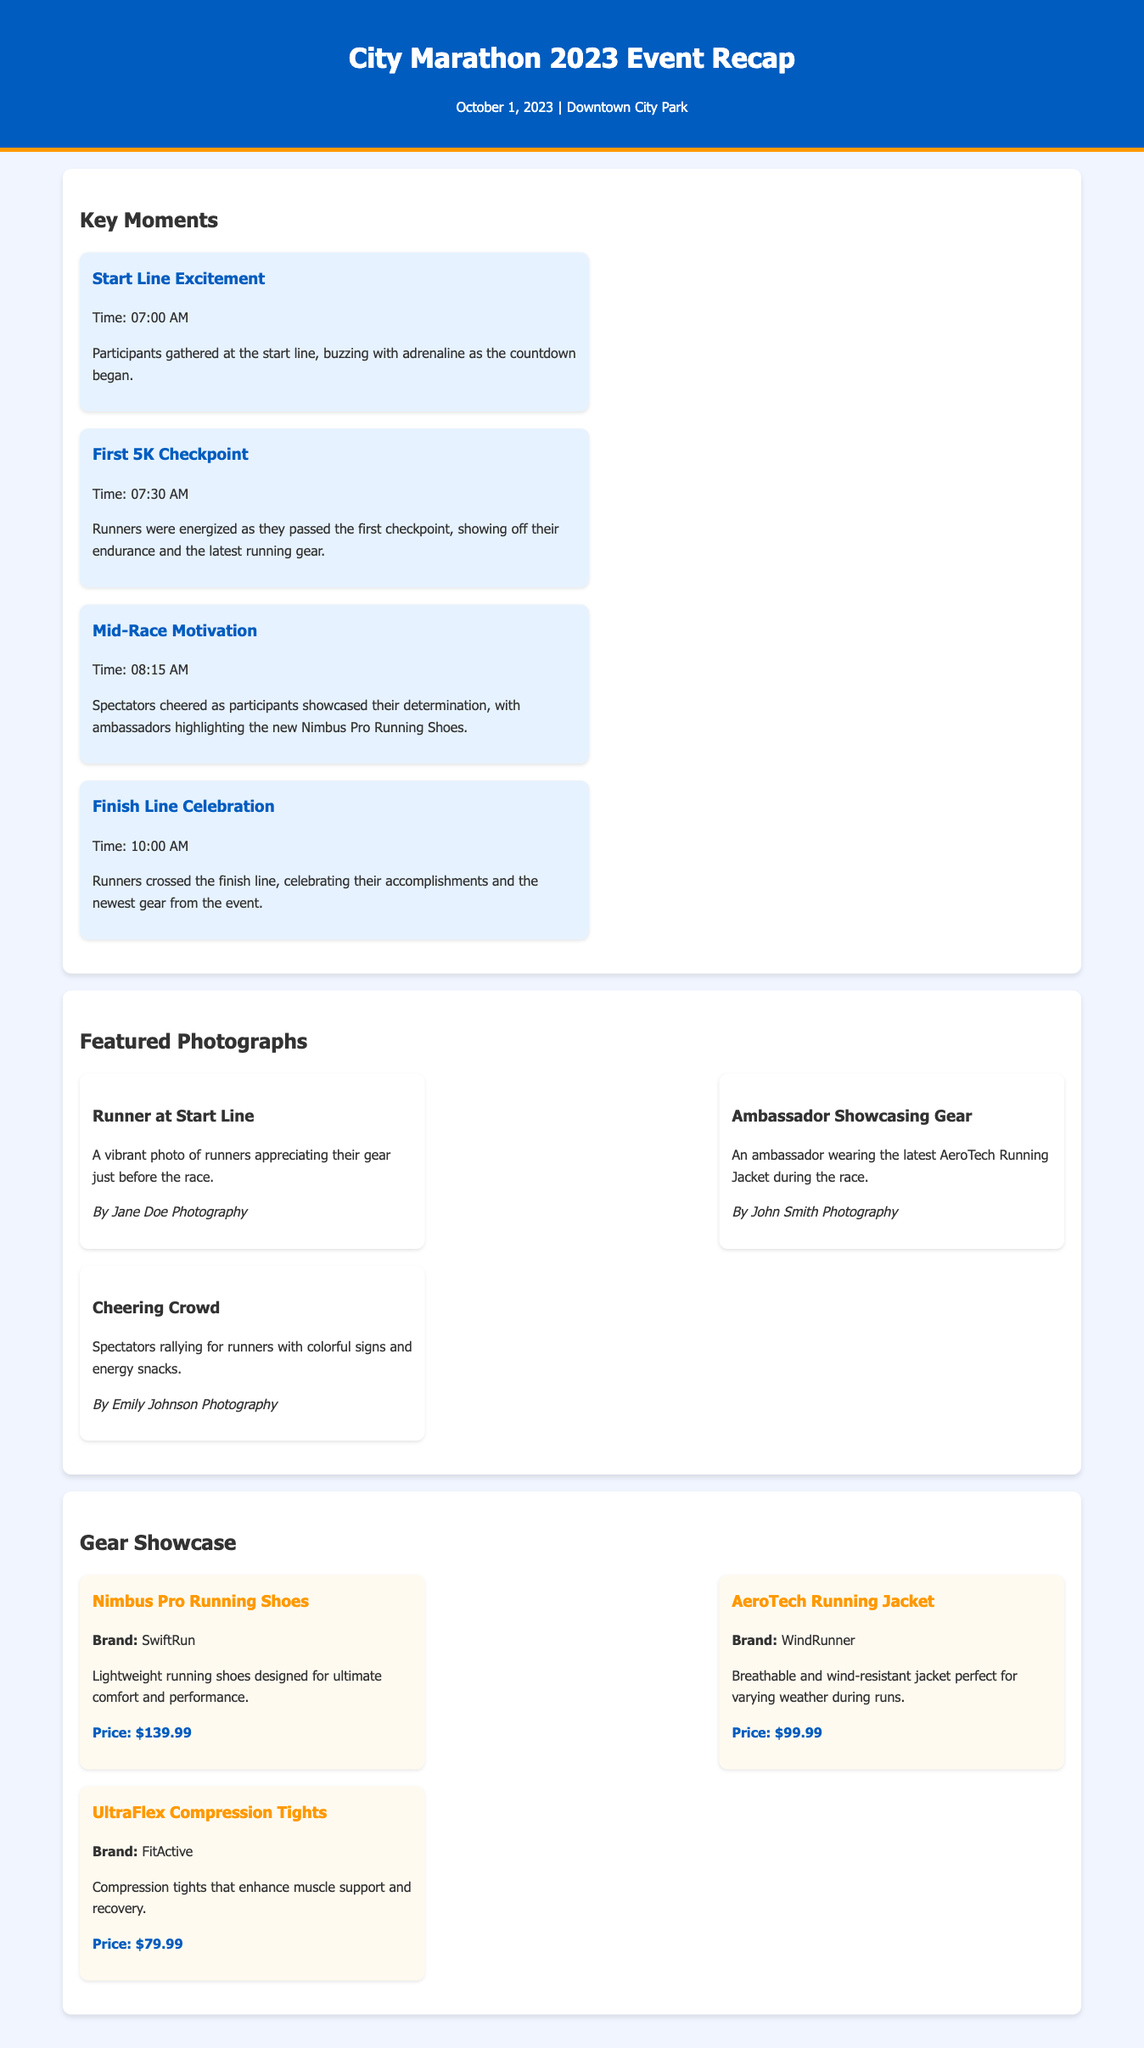What time did the City Marathon start? The City Marathon started at 07:00 AM as indicated in the key moments section.
Answer: 07:00 AM Who was the photographer for the "Runner at Start Line" photo? The photo "Runner at Start Line" was taken by Jane Doe Photography.
Answer: Jane Doe Photography What is the price of the Nimbus Pro Running Shoes? The Nimbus Pro Running Shoes are priced at $139.99 as noted in the gear showcase section.
Answer: $139.99 Which gear was an ambassador showcasing during the race? The ambassador showcased the AeroTech Running Jacket during the race.
Answer: AeroTech Running Jacket What was highlighted at the Mid-Race Motivation moment? The Mid-Race Motivation moment highlighted the new Nimbus Pro Running Shoes as per the key moments.
Answer: Nimbus Pro Running Shoes How many key moments are listed in the event recap? There are four key moments listed in the event recap.
Answer: Four What type of jacket is the AeroTech Running Jacket described as? The AeroTech Running Jacket is described as breathable and wind-resistant in the gear showcase.
Answer: Breathable and wind-resistant What was the atmosphere at the finish line? The finish line atmosphere was celebratory as runners crossed the finish line, according to the key moments.
Answer: Celebratory When did the First 5K Checkpoint occur? The First 5K Checkpoint occurred at 07:30 AM as mentioned in the key moments section.
Answer: 07:30 AM 